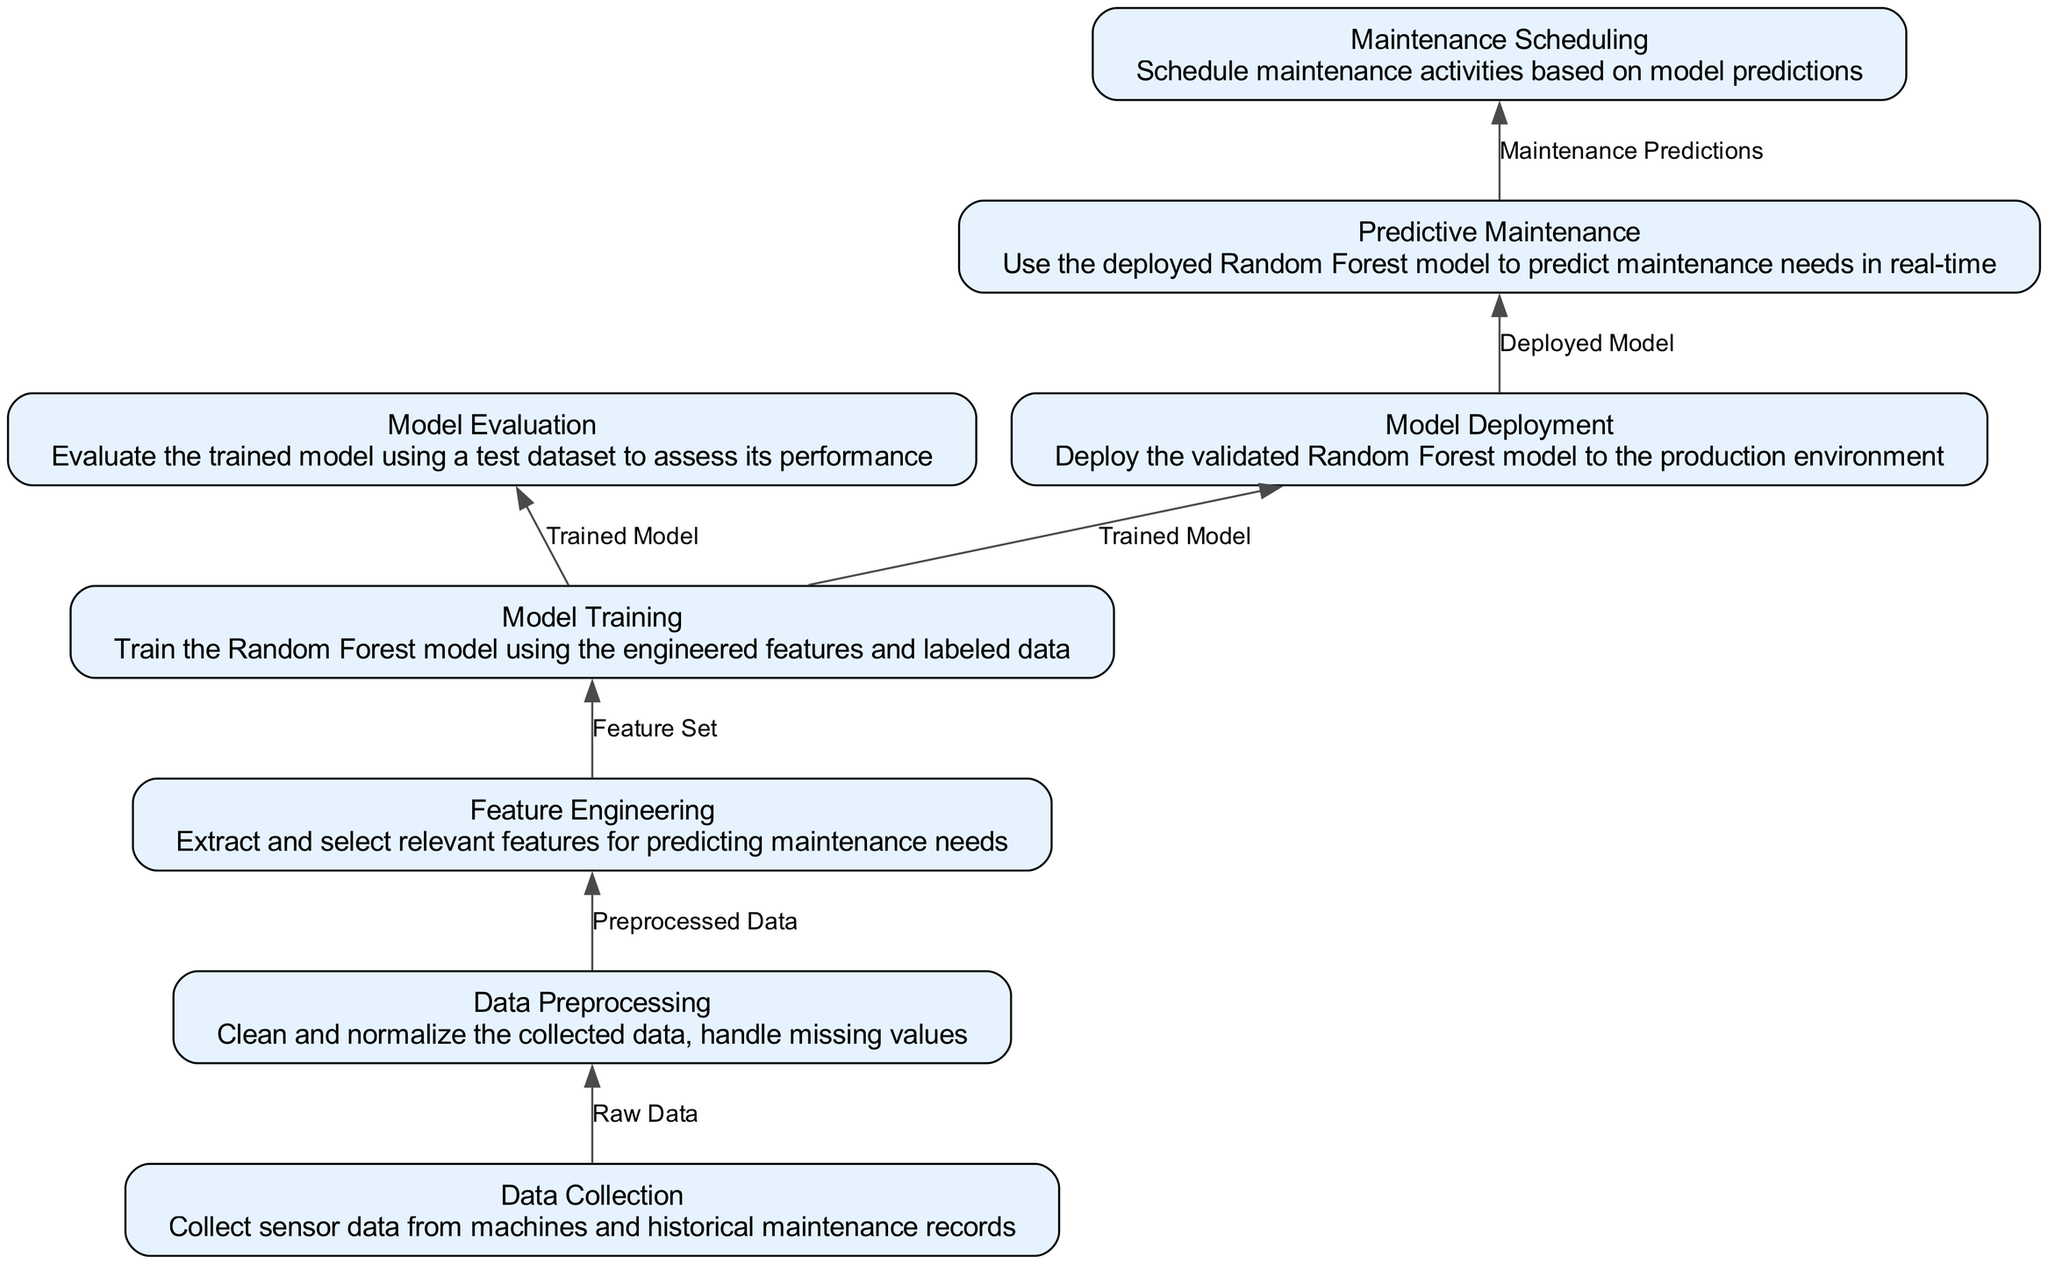What is the first step in the flow? The flow starts with the "Data Collection" step, which is the first element listed in the diagram. It does not have any inputs and is the foundation for the entire process.
Answer: Data Collection How many outputs does the "Model Evaluation" step produce? The "Model Evaluation" step has one output, which is "Model Metrics." This can be verified by checking the outputs listed for this specific element in the diagram.
Answer: One What node directly follows "Feature Engineering"? The node that directly follows "Feature Engineering" in the flow is "Model Training," as "Feature Set" is an output for "Feature Engineering" and an input for "Model Training."
Answer: Model Training What is the last stage in the predictive maintenance model implementation? The last stage of the process is "Maintenance Scheduling," which utilizes the predictions from the previous nodes to create a maintenance schedule.
Answer: Maintenance Scheduling Which step involves handling missing data? The step that involves handling missing values is "Data Preprocessing." This step aims to clean and normalize the data collected in the previous step.
Answer: Data Preprocessing How many distinct steps are there in total in the diagram? There are eight distinct steps in the flow diagram, as indicated by the number of elements listed under "elements." Each represents a critical part of the process.
Answer: Eight Which two steps are directly related to the "Trained Model"? The two steps directly related to the "Trained Model" are "Model Training," which produces the Trained Model, and "Model Evaluation," which evaluates its performance. This relationship can be traced by following the flow.
Answer: Model Training and Model Evaluation What does the "Predictive Maintenance" step use as input? The "Predictive Maintenance" step uses "Deployed Model" and "Live Sensor Data" as inputs to predict maintenance needs in real-time. This input is clearly defined in the flow.
Answer: Deployed Model and Live Sensor Data Which step leads to "Data Preprocessing"? The step that leads to "Data Preprocessing" is "Data Collection," as it provides the raw data needed to begin the preprocessing workflow.
Answer: Data Collection 